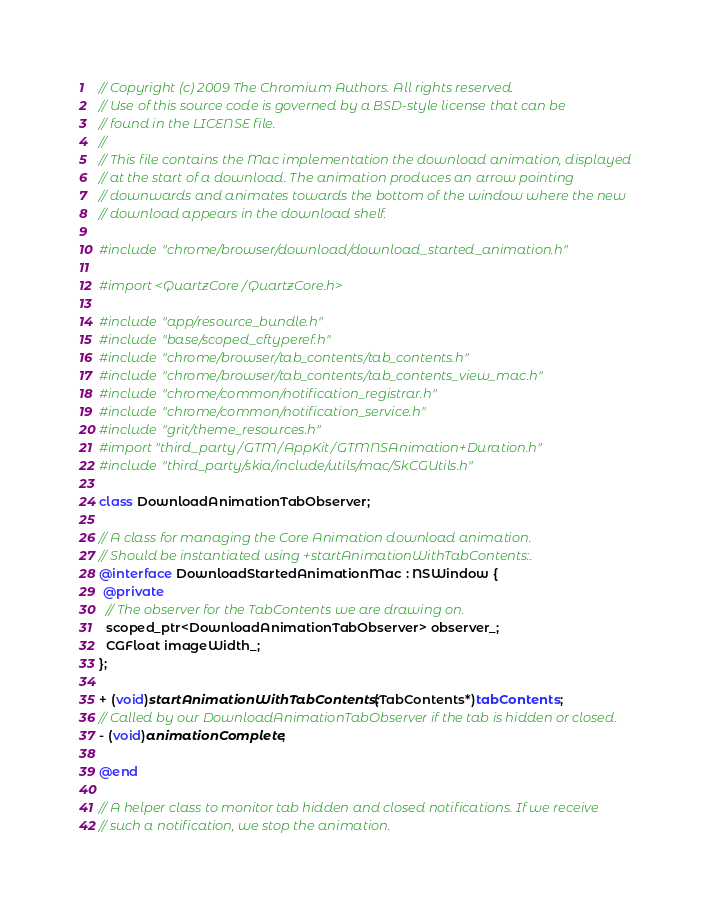<code> <loc_0><loc_0><loc_500><loc_500><_ObjectiveC_>// Copyright (c) 2009 The Chromium Authors. All rights reserved.
// Use of this source code is governed by a BSD-style license that can be
// found in the LICENSE file.
//
// This file contains the Mac implementation the download animation, displayed
// at the start of a download. The animation produces an arrow pointing
// downwards and animates towards the bottom of the window where the new
// download appears in the download shelf.

#include "chrome/browser/download/download_started_animation.h"

#import <QuartzCore/QuartzCore.h>

#include "app/resource_bundle.h"
#include "base/scoped_cftyperef.h"
#include "chrome/browser/tab_contents/tab_contents.h"
#include "chrome/browser/tab_contents/tab_contents_view_mac.h"
#include "chrome/common/notification_registrar.h"
#include "chrome/common/notification_service.h"
#include "grit/theme_resources.h"
#import "third_party/GTM/AppKit/GTMNSAnimation+Duration.h"
#include "third_party/skia/include/utils/mac/SkCGUtils.h"

class DownloadAnimationTabObserver;

// A class for managing the Core Animation download animation.
// Should be instantiated using +startAnimationWithTabContents:.
@interface DownloadStartedAnimationMac : NSWindow {
 @private
  // The observer for the TabContents we are drawing on.
  scoped_ptr<DownloadAnimationTabObserver> observer_;
  CGFloat imageWidth_;
};

+ (void)startAnimationWithTabContents:(TabContents*)tabContents;
// Called by our DownloadAnimationTabObserver if the tab is hidden or closed.
- (void)animationComplete;

@end

// A helper class to monitor tab hidden and closed notifications. If we receive
// such a notification, we stop the animation.</code> 